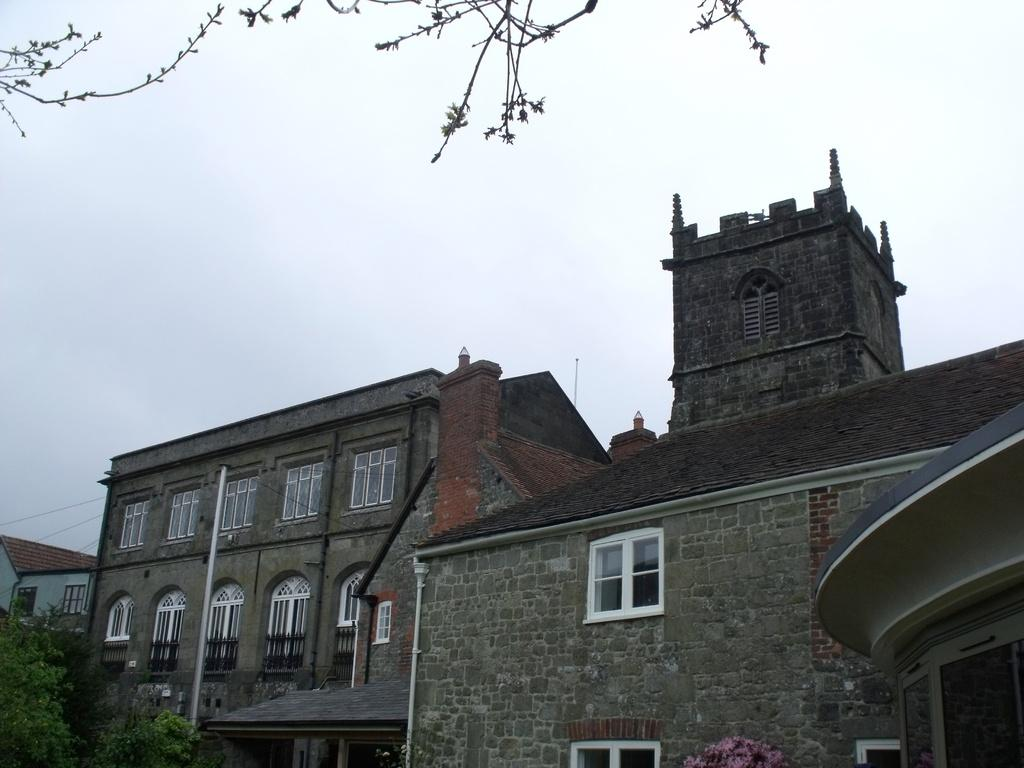What type of structures can be seen in the image? There are buildings in the image. What other natural elements are present in the image? There are trees in the image. What can be seen above the buildings and trees in the image? The sky is visible in the image. How many ladybugs can be seen on the buildings in the image? There are no ladybugs present in the image; it only features buildings, trees, and the sky. 